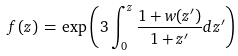<formula> <loc_0><loc_0><loc_500><loc_500>f ( z ) \, = \, \exp \left ( 3 \int _ { 0 } ^ { z } { \frac { 1 + w ( z ^ { \prime } ) } { 1 + z ^ { \prime } } d z ^ { \prime } } \right )</formula> 